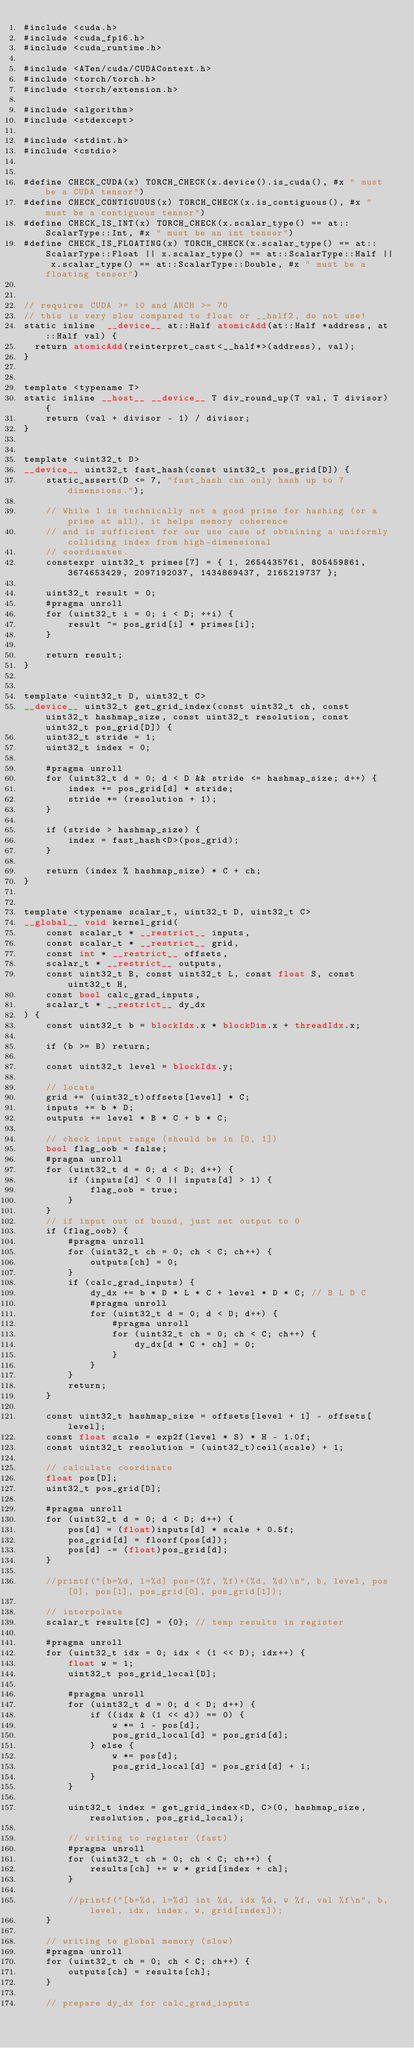Convert code to text. <code><loc_0><loc_0><loc_500><loc_500><_Cuda_>#include <cuda.h>
#include <cuda_fp16.h>
#include <cuda_runtime.h>

#include <ATen/cuda/CUDAContext.h>
#include <torch/torch.h>
#include <torch/extension.h>

#include <algorithm>
#include <stdexcept>

#include <stdint.h>
#include <cstdio>


#define CHECK_CUDA(x) TORCH_CHECK(x.device().is_cuda(), #x " must be a CUDA tensor")
#define CHECK_CONTIGUOUS(x) TORCH_CHECK(x.is_contiguous(), #x " must be a contiguous tensor")
#define CHECK_IS_INT(x) TORCH_CHECK(x.scalar_type() == at::ScalarType::Int, #x " must be an int tensor")
#define CHECK_IS_FLOATING(x) TORCH_CHECK(x.scalar_type() == at::ScalarType::Float || x.scalar_type() == at::ScalarType::Half || x.scalar_type() == at::ScalarType::Double, #x " must be a floating tensor")


// requires CUDA >= 10 and ARCH >= 70
// this is very slow compared to float or __half2, do not use!
static inline  __device__ at::Half atomicAdd(at::Half *address, at::Half val) {
  return atomicAdd(reinterpret_cast<__half*>(address), val);
}


template <typename T>
static inline __host__ __device__ T div_round_up(T val, T divisor) {
    return (val + divisor - 1) / divisor;
}


template <uint32_t D>
__device__ uint32_t fast_hash(const uint32_t pos_grid[D]) {
    static_assert(D <= 7, "fast_hash can only hash up to 7 dimensions.");

    // While 1 is technically not a good prime for hashing (or a prime at all), it helps memory coherence
    // and is sufficient for our use case of obtaining a uniformly colliding index from high-dimensional
    // coordinates.
    constexpr uint32_t primes[7] = { 1, 2654435761, 805459861, 3674653429, 2097192037, 1434869437, 2165219737 };

    uint32_t result = 0;
    #pragma unroll
    for (uint32_t i = 0; i < D; ++i) {
        result ^= pos_grid[i] * primes[i];
    }

    return result;
}


template <uint32_t D, uint32_t C>
__device__ uint32_t get_grid_index(const uint32_t ch, const uint32_t hashmap_size, const uint32_t resolution, const uint32_t pos_grid[D]) {
    uint32_t stride = 1;
    uint32_t index = 0;

    #pragma unroll
    for (uint32_t d = 0; d < D && stride <= hashmap_size; d++) {
        index += pos_grid[d] * stride;
        stride *= (resolution + 1);
    }

    if (stride > hashmap_size) {
        index = fast_hash<D>(pos_grid);
    }

    return (index % hashmap_size) * C + ch;
}


template <typename scalar_t, uint32_t D, uint32_t C>
__global__ void kernel_grid(
    const scalar_t * __restrict__ inputs, 
    const scalar_t * __restrict__ grid, 
    const int * __restrict__ offsets, 
    scalar_t * __restrict__ outputs, 
    const uint32_t B, const uint32_t L, const float S, const uint32_t H,
    const bool calc_grad_inputs, 
    scalar_t * __restrict__ dy_dx
) {
    const uint32_t b = blockIdx.x * blockDim.x + threadIdx.x;
    
    if (b >= B) return;

    const uint32_t level = blockIdx.y;
    
    // locate
    grid += (uint32_t)offsets[level] * C;
    inputs += b * D;
    outputs += level * B * C + b * C;

    // check input range (should be in [0, 1])
    bool flag_oob = false;
    #pragma unroll
    for (uint32_t d = 0; d < D; d++) {
        if (inputs[d] < 0 || inputs[d] > 1) {
            flag_oob = true;
        }
    }
    // if input out of bound, just set output to 0
    if (flag_oob) {
        #pragma unroll
        for (uint32_t ch = 0; ch < C; ch++) {
            outputs[ch] = 0; 
        }
        if (calc_grad_inputs) {
            dy_dx += b * D * L * C + level * D * C; // B L D C
            #pragma unroll
            for (uint32_t d = 0; d < D; d++) {
                #pragma unroll
                for (uint32_t ch = 0; ch < C; ch++) {
                    dy_dx[d * C + ch] = 0; 
                }       
            }
        }
        return;
    }

    const uint32_t hashmap_size = offsets[level + 1] - offsets[level];
    const float scale = exp2f(level * S) * H - 1.0f;
    const uint32_t resolution = (uint32_t)ceil(scale) + 1;
    
    // calculate coordinate
    float pos[D];
    uint32_t pos_grid[D];

    #pragma unroll
    for (uint32_t d = 0; d < D; d++) {
        pos[d] = (float)inputs[d] * scale + 0.5f;
        pos_grid[d] = floorf(pos[d]);
        pos[d] -= (float)pos_grid[d];
    }

    //printf("[b=%d, l=%d] pos=(%f, %f)+(%d, %d)\n", b, level, pos[0], pos[1], pos_grid[0], pos_grid[1]);

    // interpolate
    scalar_t results[C] = {0}; // temp results in register

    #pragma unroll
    for (uint32_t idx = 0; idx < (1 << D); idx++) {
        float w = 1;
        uint32_t pos_grid_local[D];

        #pragma unroll
        for (uint32_t d = 0; d < D; d++) {
            if ((idx & (1 << d)) == 0) {
                w *= 1 - pos[d];
                pos_grid_local[d] = pos_grid[d];
            } else {
                w *= pos[d];
                pos_grid_local[d] = pos_grid[d] + 1;
            }
        }

        uint32_t index = get_grid_index<D, C>(0, hashmap_size, resolution, pos_grid_local);

        // writing to register (fast)
        #pragma unroll
        for (uint32_t ch = 0; ch < C; ch++) {
            results[ch] += w * grid[index + ch];
        }

        //printf("[b=%d, l=%d] int %d, idx %d, w %f, val %f\n", b, level, idx, index, w, grid[index]);
    }    

    // writing to global memory (slow)
    #pragma unroll
    for (uint32_t ch = 0; ch < C; ch++) {
        outputs[ch] = results[ch]; 
    }

    // prepare dy_dx for calc_grad_inputs</code> 